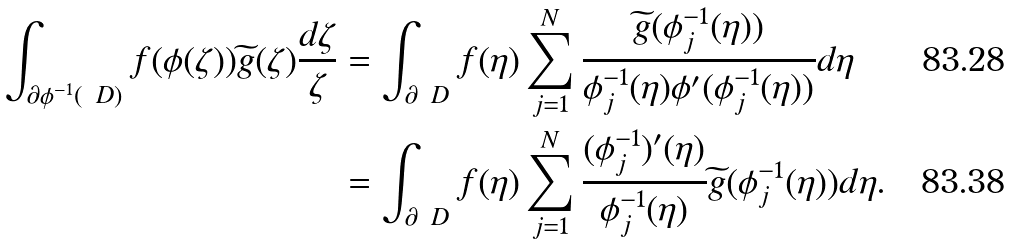<formula> <loc_0><loc_0><loc_500><loc_500>\int _ { \partial \phi ^ { - 1 } ( \ D ) } f ( \phi ( \zeta ) ) \widetilde { g } ( \zeta ) \frac { d \zeta } { \zeta } & = \int _ { \partial \ D } f ( \eta ) \sum _ { j = 1 } ^ { N } \frac { \widetilde { g } ( \phi _ { j } ^ { - 1 } ( \eta ) ) } { \phi _ { j } ^ { - 1 } ( \eta ) \phi ^ { \prime } ( \phi _ { j } ^ { - 1 } ( \eta ) ) } d \eta \\ & = \int _ { \partial \ D } f ( \eta ) \sum _ { j = 1 } ^ { N } \frac { ( \phi _ { j } ^ { - 1 } ) ^ { \prime } ( \eta ) } { \phi _ { j } ^ { - 1 } ( \eta ) } \widetilde { g } ( \phi _ { j } ^ { - 1 } ( \eta ) ) d \eta \text {.}</formula> 